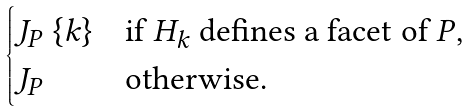<formula> <loc_0><loc_0><loc_500><loc_500>\begin{cases} J _ { P } \ \{ k \} & \text {if $H_{k}$ defines a facet of $P$} , \\ J _ { P } & \text {otherwise} . \end{cases}</formula> 